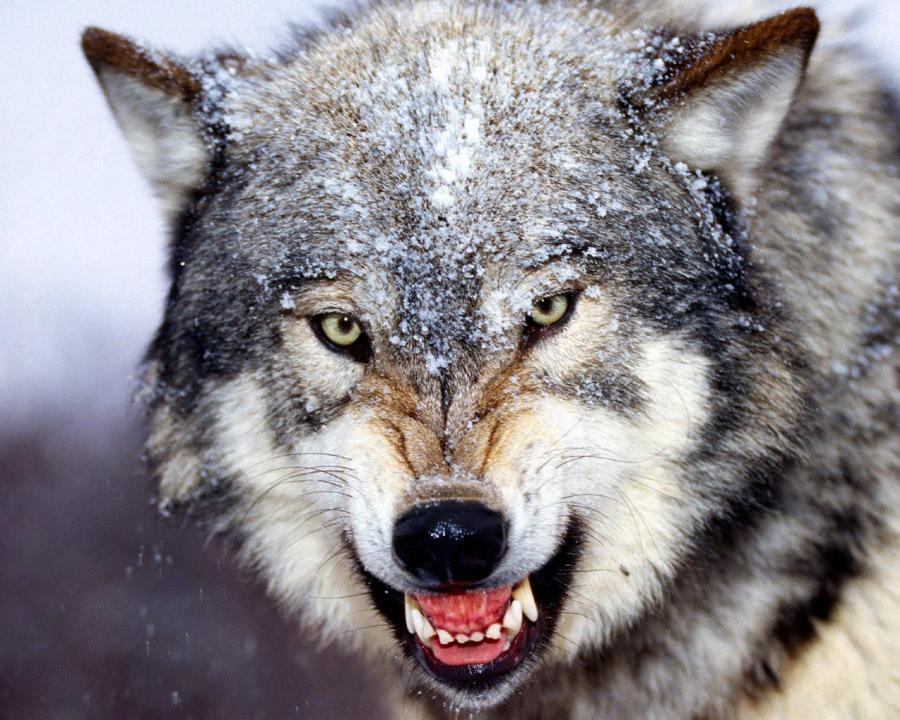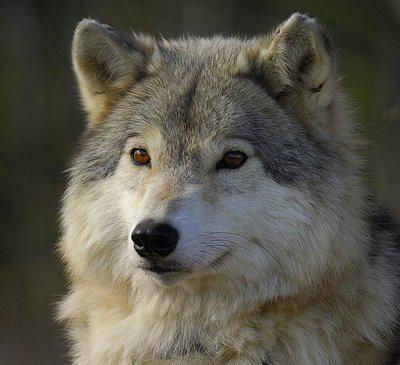The first image is the image on the left, the second image is the image on the right. Considering the images on both sides, is "There are more than one animal in the image on the left." valid? Answer yes or no. No. 